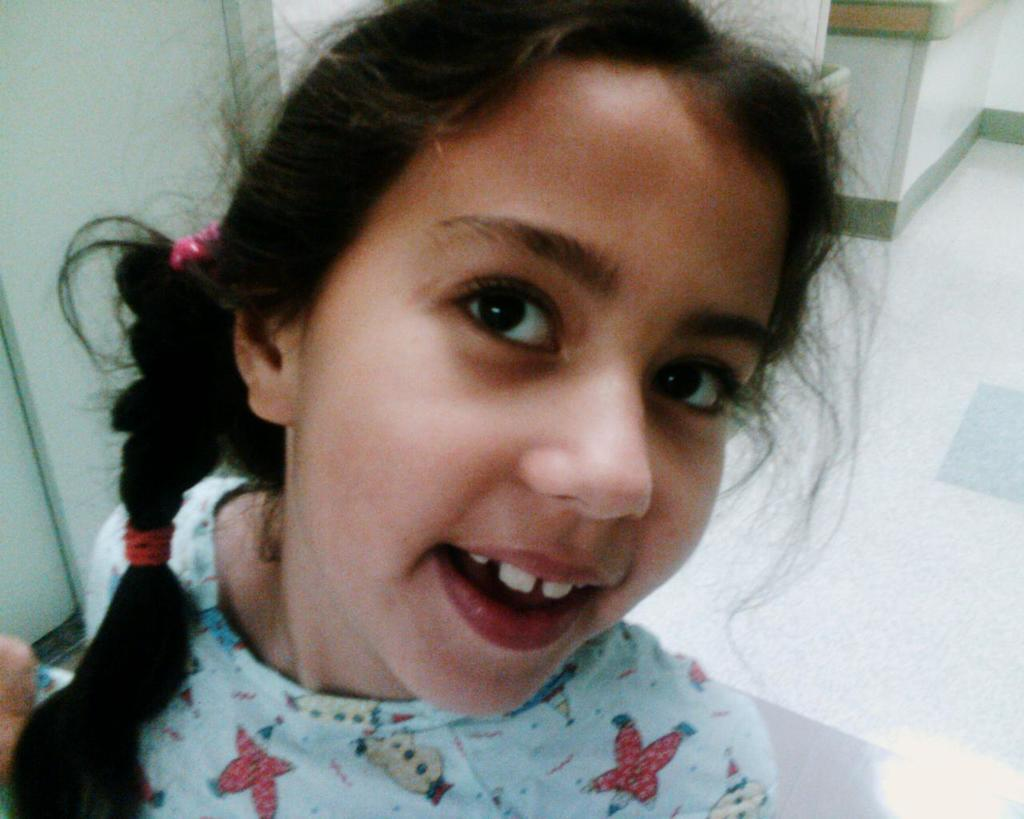Who is the main subject in the image? There is a girl in the image. What is the girl wearing? The girl is wearing a blue t-shirt. What color is the floor in the image? The floor in the image is white. What color are the walls in the image? The walls in the image are white. How many cars can be seen in the image? There are no cars present in the image. What type of trick is the girl performing in the image? There is no trick being performed in the image; the girl is simply standing or posing. 